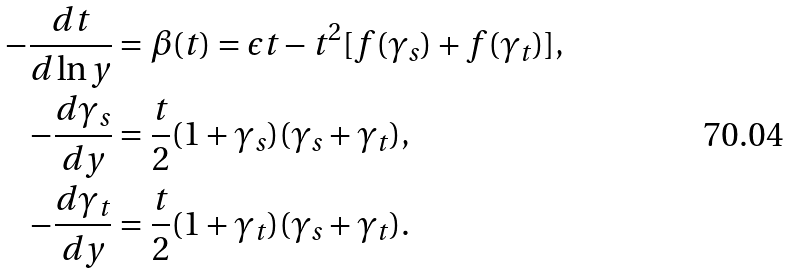<formula> <loc_0><loc_0><loc_500><loc_500>- \frac { d t } { d \ln y } & = \beta ( t ) = \epsilon t - t ^ { 2 } [ f ( \gamma _ { s } ) + f ( \gamma _ { t } ) ] , \\ - \frac { d \gamma _ { s } } { d y } & = \frac { t } { 2 } ( 1 + \gamma _ { s } ) ( \gamma _ { s } + \gamma _ { t } ) , \\ - \frac { d \gamma _ { t } } { d y } & = \frac { t } { 2 } ( 1 + \gamma _ { t } ) ( \gamma _ { s } + \gamma _ { t } ) .</formula> 